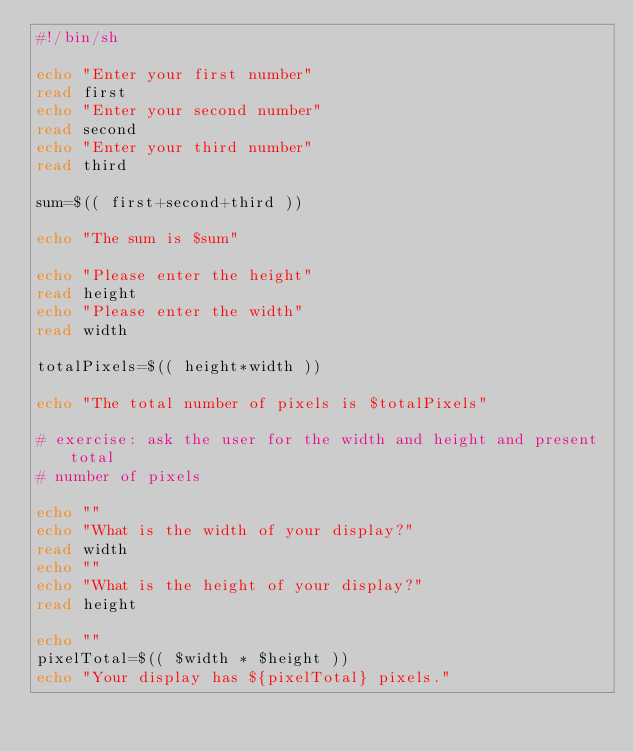Convert code to text. <code><loc_0><loc_0><loc_500><loc_500><_Bash_>#!/bin/sh

echo "Enter your first number"
read first
echo "Enter your second number"
read second
echo "Enter your third number"
read third

sum=$(( first+second+third ))

echo "The sum is $sum"

echo "Please enter the height"
read height
echo "Please enter the width"
read width

totalPixels=$(( height*width ))

echo "The total number of pixels is $totalPixels"

# exercise: ask the user for the width and height and present total
# number of pixels

echo ""
echo "What is the width of your display?"
read width
echo ""
echo "What is the height of your display?"
read height

echo ""
pixelTotal=$(( $width * $height ))
echo "Your display has ${pixelTotal} pixels." 
</code> 